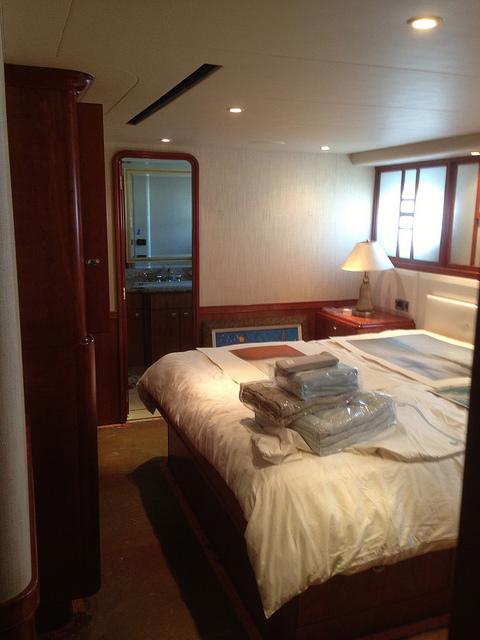What room is this?
Quick response, please. Bedroom. Is there any laundry on top of the bed?
Write a very short answer. Yes. Does the room have drapes?
Quick response, please. No. What color is the comforter?
Concise answer only. White. 